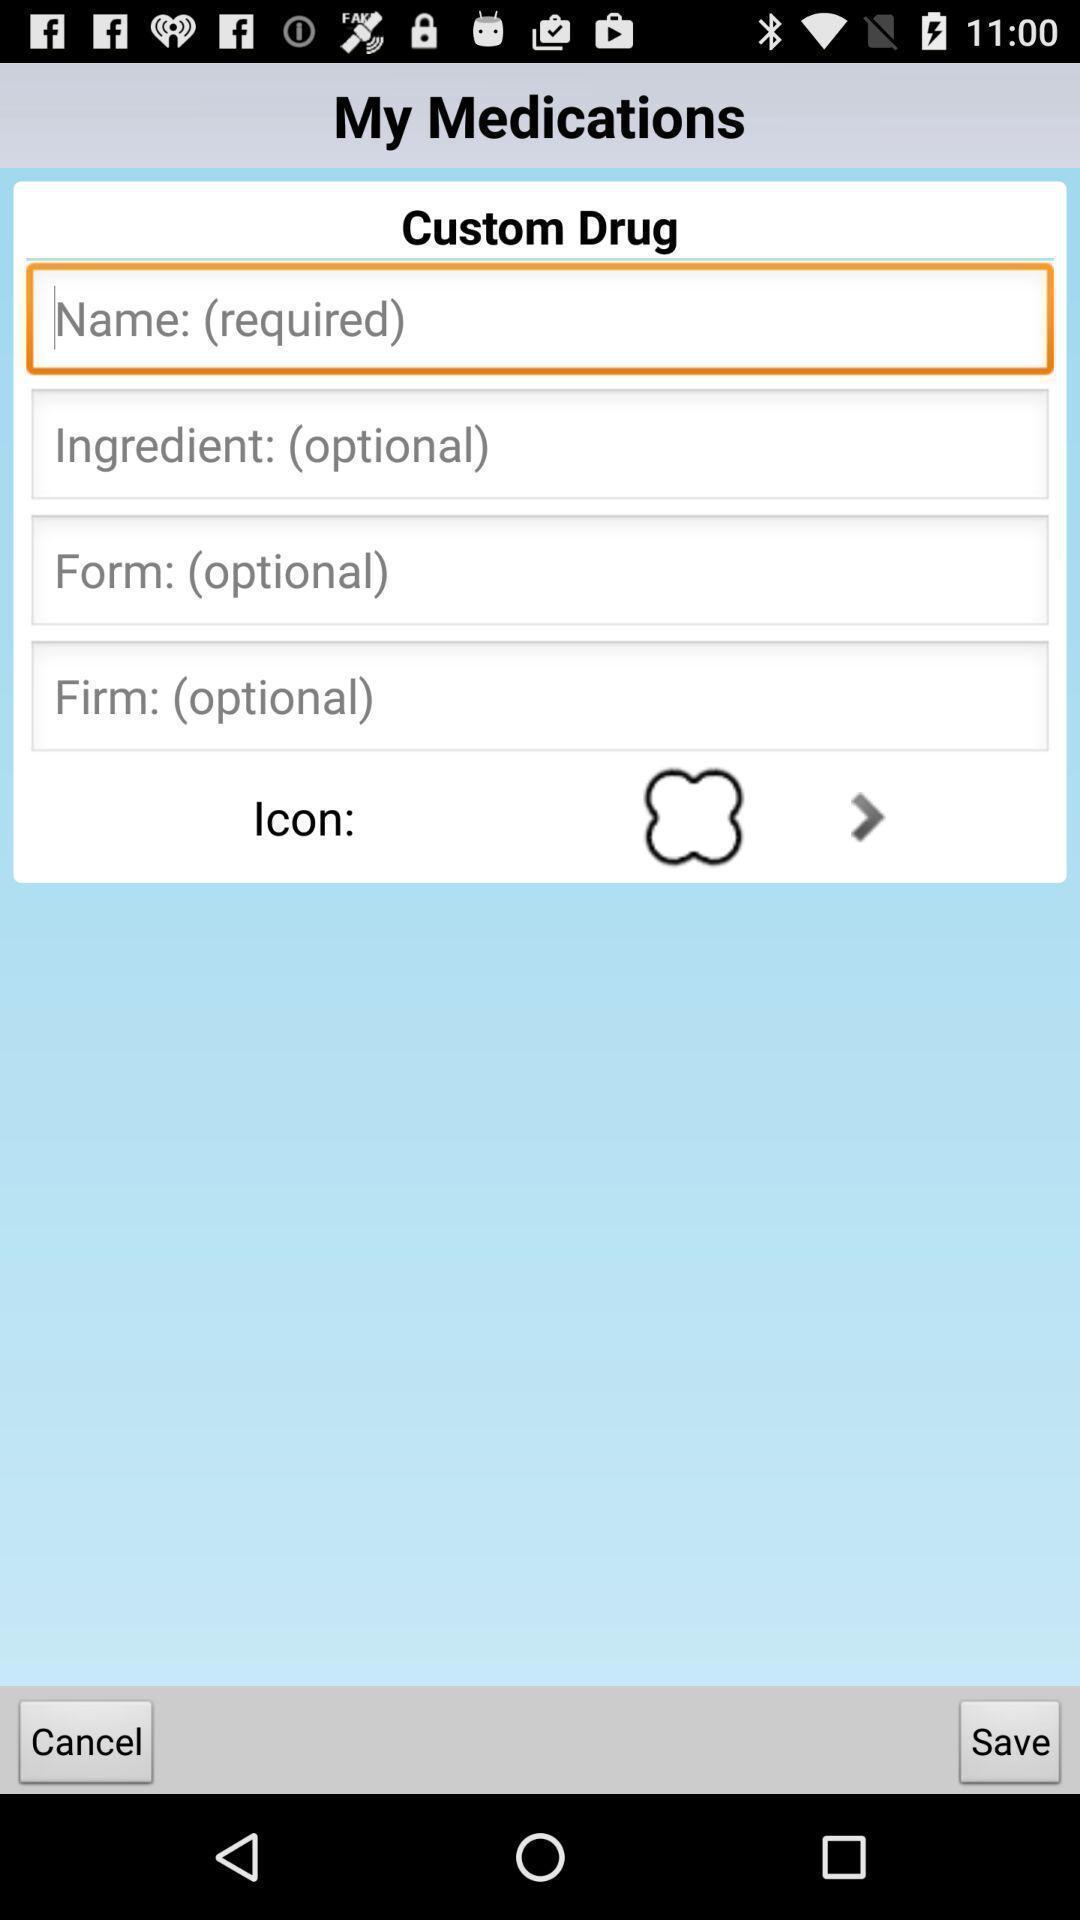Give me a summary of this screen capture. Screen display my medications page. 